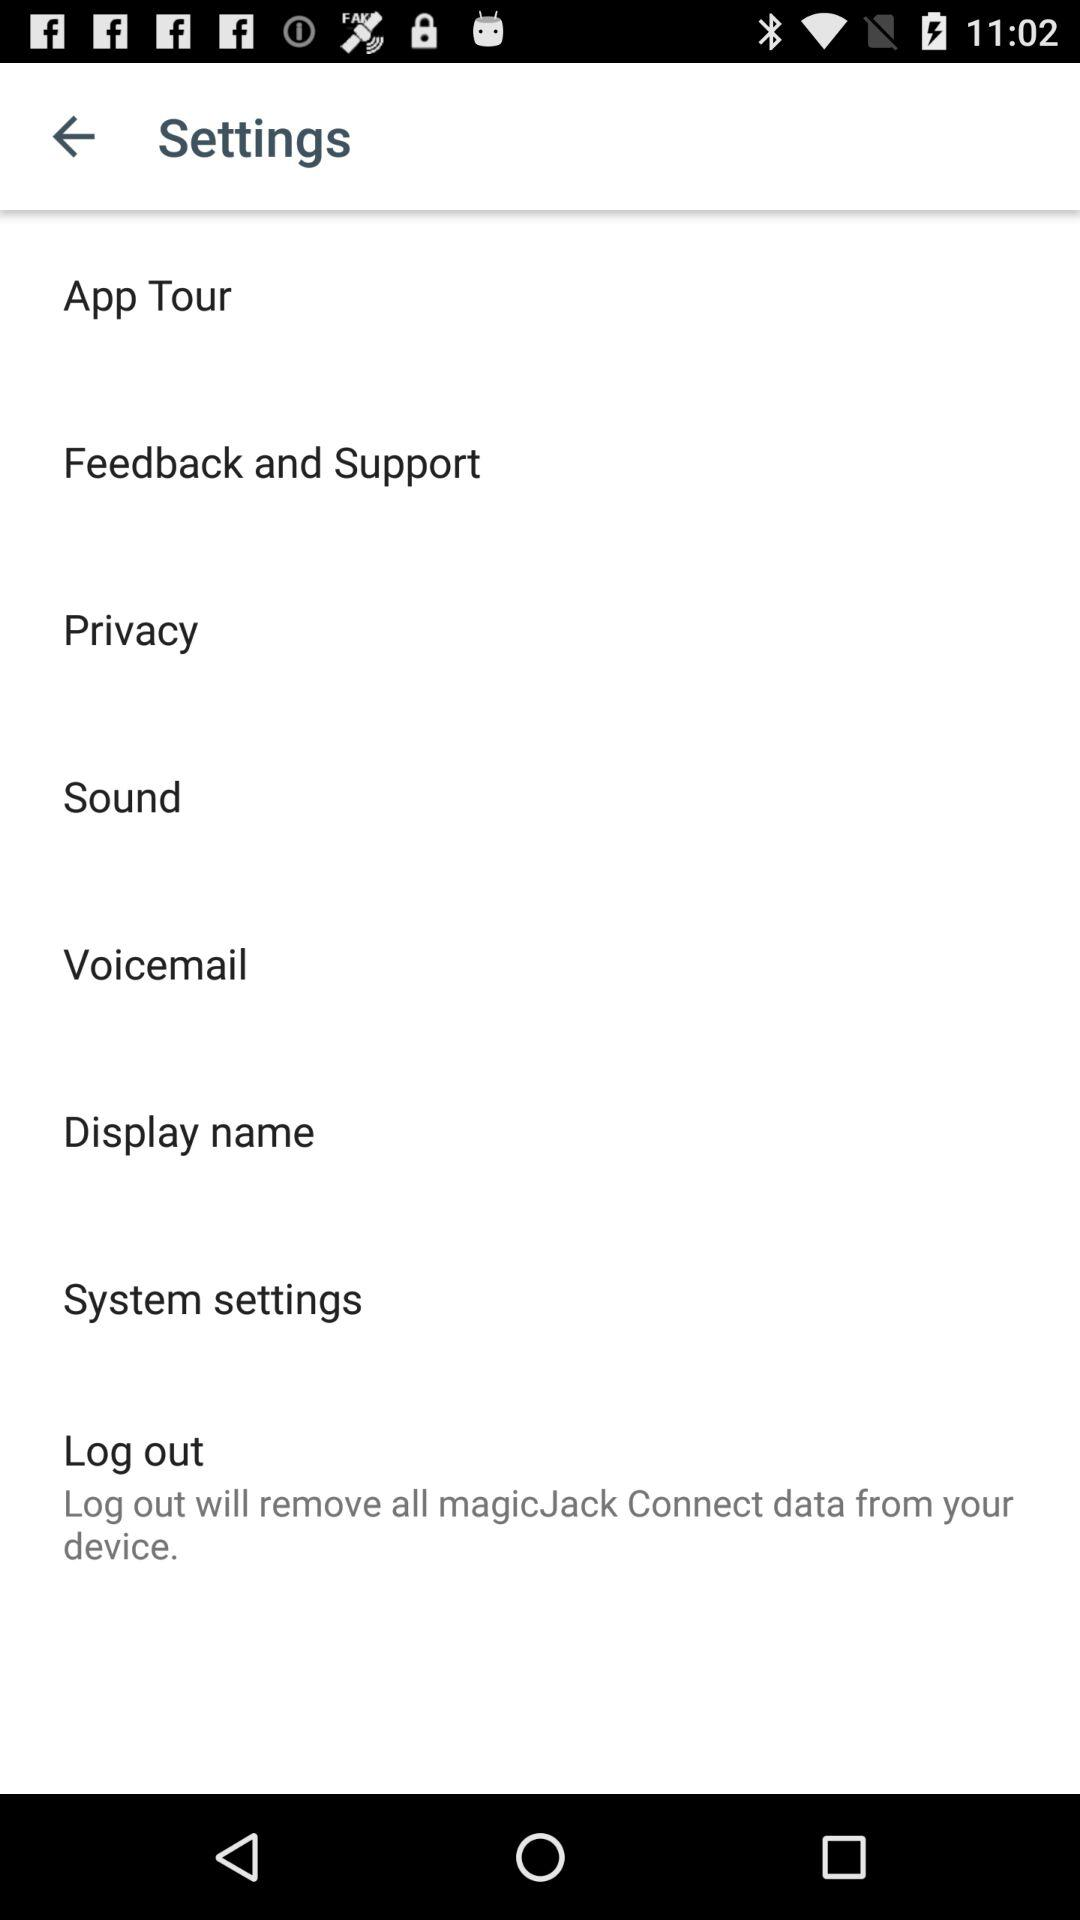What will be removed on logging out? Logging out will remove all "magicJack Connect" data from your device. 